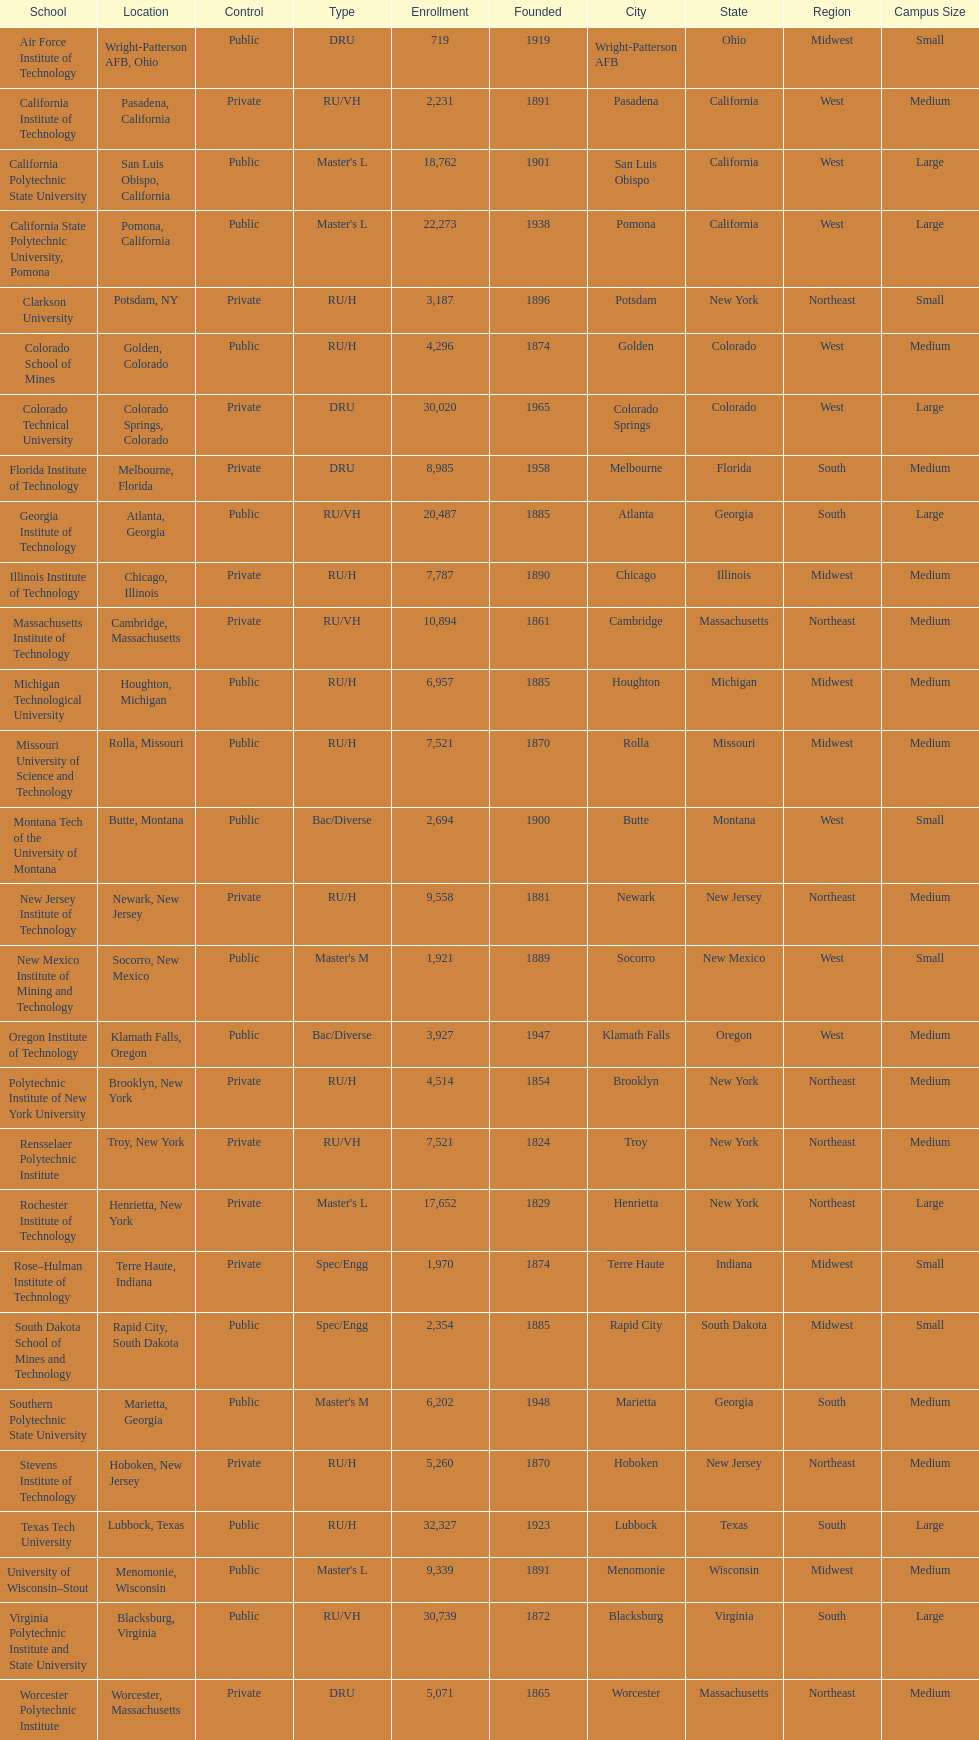Could you parse the entire table as a dict? {'header': ['School', 'Location', 'Control', 'Type', 'Enrollment', 'Founded', 'City', 'State', 'Region', 'Campus Size'], 'rows': [['Air Force Institute of Technology', 'Wright-Patterson AFB, Ohio', 'Public', 'DRU', '719', '1919', 'Wright-Patterson AFB', 'Ohio', 'Midwest', 'Small'], ['California Institute of Technology', 'Pasadena, California', 'Private', 'RU/VH', '2,231', '1891', 'Pasadena', 'California', 'West', 'Medium'], ['California Polytechnic State University', 'San Luis Obispo, California', 'Public', "Master's L", '18,762', '1901', 'San Luis Obispo', 'California', 'West', 'Large'], ['California State Polytechnic University, Pomona', 'Pomona, California', 'Public', "Master's L", '22,273', '1938', 'Pomona', 'California', 'West', 'Large'], ['Clarkson University', 'Potsdam, NY', 'Private', 'RU/H', '3,187', '1896', 'Potsdam', 'New York', 'Northeast', 'Small'], ['Colorado School of Mines', 'Golden, Colorado', 'Public', 'RU/H', '4,296', '1874', 'Golden', 'Colorado', 'West', 'Medium'], ['Colorado Technical University', 'Colorado Springs, Colorado', 'Private', 'DRU', '30,020', '1965', 'Colorado Springs', 'Colorado', 'West', 'Large'], ['Florida Institute of Technology', 'Melbourne, Florida', 'Private', 'DRU', '8,985', '1958', 'Melbourne', 'Florida', 'South', 'Medium'], ['Georgia Institute of Technology', 'Atlanta, Georgia', 'Public', 'RU/VH', '20,487', '1885', 'Atlanta', 'Georgia', 'South', 'Large'], ['Illinois Institute of Technology', 'Chicago, Illinois', 'Private', 'RU/H', '7,787', '1890', 'Chicago', 'Illinois', 'Midwest', 'Medium'], ['Massachusetts Institute of Technology', 'Cambridge, Massachusetts', 'Private', 'RU/VH', '10,894', '1861', 'Cambridge', 'Massachusetts', 'Northeast', 'Medium'], ['Michigan Technological University', 'Houghton, Michigan', 'Public', 'RU/H', '6,957', '1885', 'Houghton', 'Michigan', 'Midwest', 'Medium'], ['Missouri University of Science and Technology', 'Rolla, Missouri', 'Public', 'RU/H', '7,521', '1870', 'Rolla', 'Missouri', 'Midwest', 'Medium'], ['Montana Tech of the University of Montana', 'Butte, Montana', 'Public', 'Bac/Diverse', '2,694', '1900', 'Butte', 'Montana', 'West', 'Small'], ['New Jersey Institute of Technology', 'Newark, New Jersey', 'Private', 'RU/H', '9,558', '1881', 'Newark', 'New Jersey', 'Northeast', 'Medium'], ['New Mexico Institute of Mining and Technology', 'Socorro, New Mexico', 'Public', "Master's M", '1,921', '1889', 'Socorro', 'New Mexico', 'West', 'Small'], ['Oregon Institute of Technology', 'Klamath Falls, Oregon', 'Public', 'Bac/Diverse', '3,927', '1947', 'Klamath Falls', 'Oregon', 'West', 'Medium'], ['Polytechnic Institute of New York University', 'Brooklyn, New York', 'Private', 'RU/H', '4,514', '1854', 'Brooklyn', 'New York', 'Northeast', 'Medium'], ['Rensselaer Polytechnic Institute', 'Troy, New York', 'Private', 'RU/VH', '7,521', '1824', 'Troy', 'New York', 'Northeast', 'Medium'], ['Rochester Institute of Technology', 'Henrietta, New York', 'Private', "Master's L", '17,652', '1829', 'Henrietta', 'New York', 'Northeast', 'Large'], ['Rose–Hulman Institute of Technology', 'Terre Haute, Indiana', 'Private', 'Spec/Engg', '1,970', '1874', 'Terre Haute', 'Indiana', 'Midwest', 'Small'], ['South Dakota School of Mines and Technology', 'Rapid City, South Dakota', 'Public', 'Spec/Engg', '2,354', '1885', 'Rapid City', 'South Dakota', 'Midwest', 'Small'], ['Southern Polytechnic State University', 'Marietta, Georgia', 'Public', "Master's M", '6,202', '1948', 'Marietta', 'Georgia', 'South', 'Medium'], ['Stevens Institute of Technology', 'Hoboken, New Jersey', 'Private', 'RU/H', '5,260', '1870', 'Hoboken', 'New Jersey', 'Northeast', 'Medium'], ['Texas Tech University', 'Lubbock, Texas', 'Public', 'RU/H', '32,327', '1923', 'Lubbock', 'Texas', 'South', 'Large'], ['University of Wisconsin–Stout', 'Menomonie, Wisconsin', 'Public', "Master's L", '9,339', '1891', 'Menomonie', 'Wisconsin', 'Midwest', 'Medium'], ['Virginia Polytechnic Institute and State University', 'Blacksburg, Virginia', 'Public', 'RU/VH', '30,739', '1872', 'Blacksburg', 'Virginia', 'South', 'Large'], ['Worcester Polytechnic Institute', 'Worcester, Massachusetts', 'Private', 'DRU', '5,071', '1865', 'Worcester', 'Massachusetts', 'Northeast', 'Medium']]} Which of the universities was founded first? Rensselaer Polytechnic Institute. 